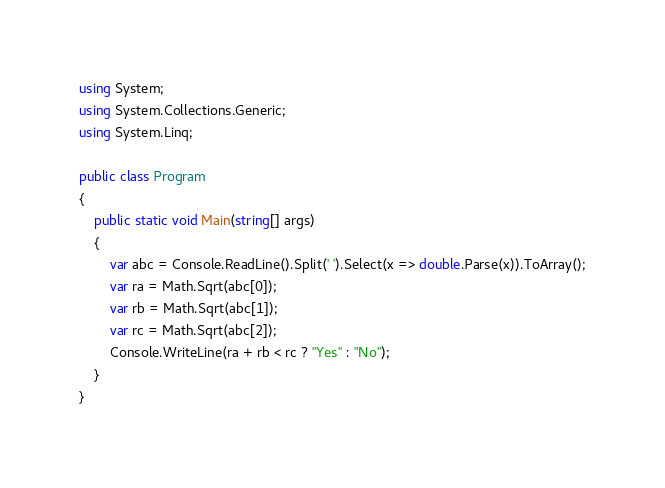Convert code to text. <code><loc_0><loc_0><loc_500><loc_500><_C#_>using System;
using System.Collections.Generic;
using System.Linq;

public class Program
{
    public static void Main(string[] args)
    {
        var abc = Console.ReadLine().Split(' ').Select(x => double.Parse(x)).ToArray();
        var ra = Math.Sqrt(abc[0]);
        var rb = Math.Sqrt(abc[1]);
        var rc = Math.Sqrt(abc[2]);
        Console.WriteLine(ra + rb < rc ? "Yes" : "No");
    }
}</code> 